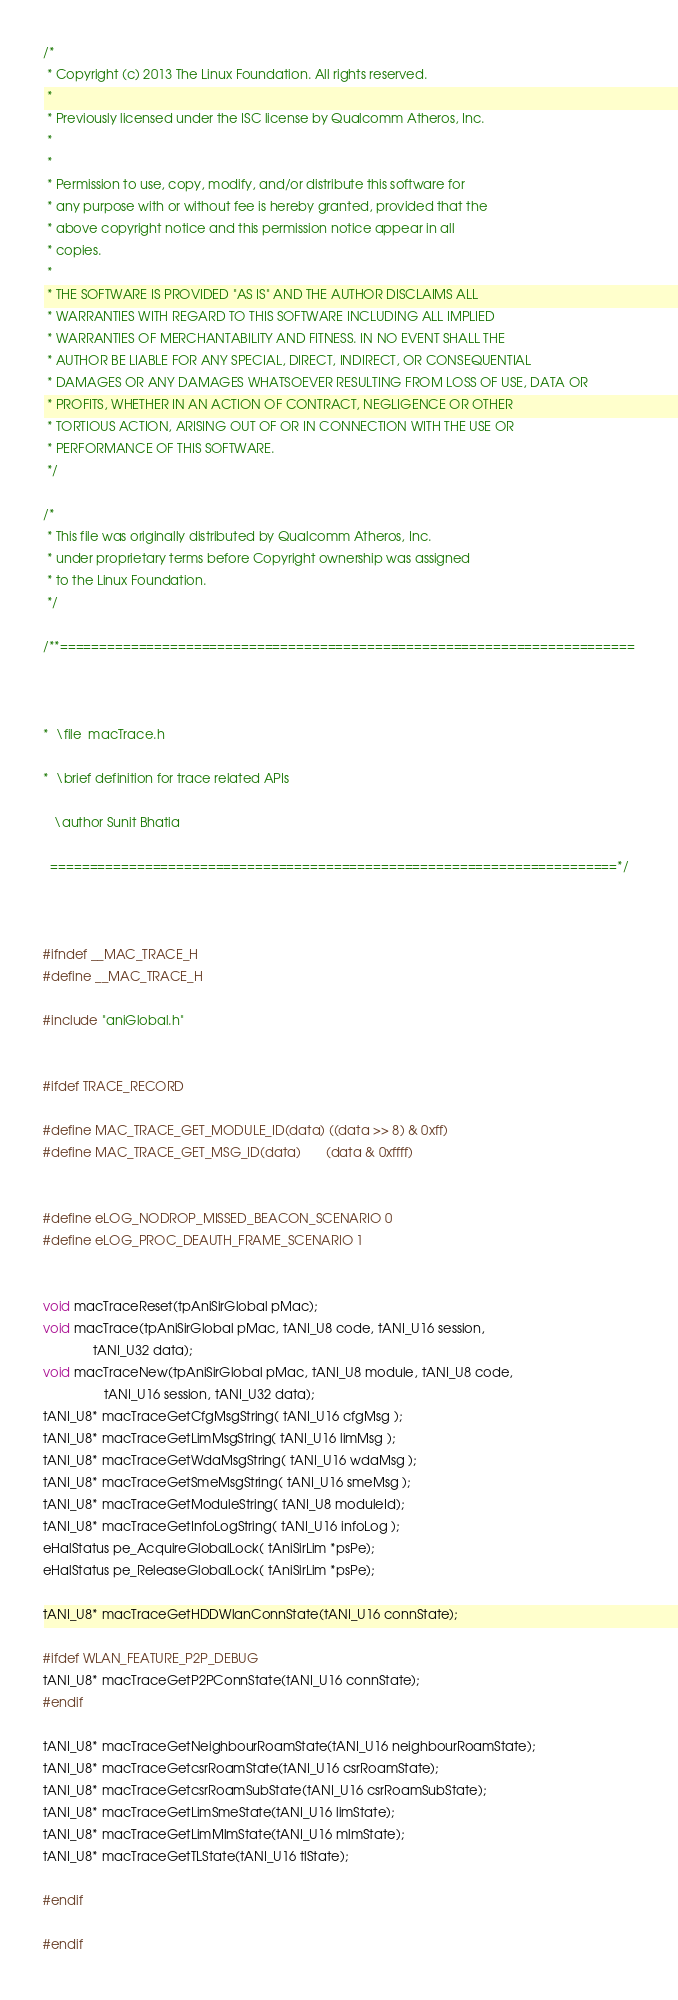<code> <loc_0><loc_0><loc_500><loc_500><_C_>/*
 * Copyright (c) 2013 The Linux Foundation. All rights reserved.
 *
 * Previously licensed under the ISC license by Qualcomm Atheros, Inc.
 *
 *
 * Permission to use, copy, modify, and/or distribute this software for
 * any purpose with or without fee is hereby granted, provided that the
 * above copyright notice and this permission notice appear in all
 * copies.
 *
 * THE SOFTWARE IS PROVIDED "AS IS" AND THE AUTHOR DISCLAIMS ALL
 * WARRANTIES WITH REGARD TO THIS SOFTWARE INCLUDING ALL IMPLIED
 * WARRANTIES OF MERCHANTABILITY AND FITNESS. IN NO EVENT SHALL THE
 * AUTHOR BE LIABLE FOR ANY SPECIAL, DIRECT, INDIRECT, OR CONSEQUENTIAL
 * DAMAGES OR ANY DAMAGES WHATSOEVER RESULTING FROM LOSS OF USE, DATA OR
 * PROFITS, WHETHER IN AN ACTION OF CONTRACT, NEGLIGENCE OR OTHER
 * TORTIOUS ACTION, ARISING OUT OF OR IN CONNECTION WITH THE USE OR
 * PERFORMANCE OF THIS SOFTWARE.
 */

/*
 * This file was originally distributed by Qualcomm Atheros, Inc.
 * under proprietary terms before Copyright ownership was assigned
 * to the Linux Foundation.
 */

/**=========================================================================



*  \file  macTrace.h

*  \brief definition for trace related APIs

   \author Sunit Bhatia

  ========================================================================*/



#ifndef __MAC_TRACE_H
#define __MAC_TRACE_H

#include "aniGlobal.h"


#ifdef TRACE_RECORD

#define MAC_TRACE_GET_MODULE_ID(data) ((data >> 8) & 0xff)
#define MAC_TRACE_GET_MSG_ID(data)       (data & 0xffff)


#define eLOG_NODROP_MISSED_BEACON_SCENARIO 0
#define eLOG_PROC_DEAUTH_FRAME_SCENARIO 1


void macTraceReset(tpAniSirGlobal pMac);
void macTrace(tpAniSirGlobal pMac, tANI_U8 code, tANI_U16 session,
              tANI_U32 data);
void macTraceNew(tpAniSirGlobal pMac, tANI_U8 module, tANI_U8 code,
                 tANI_U16 session, tANI_U32 data);
tANI_U8* macTraceGetCfgMsgString( tANI_U16 cfgMsg );
tANI_U8* macTraceGetLimMsgString( tANI_U16 limMsg );
tANI_U8* macTraceGetWdaMsgString( tANI_U16 wdaMsg );
tANI_U8* macTraceGetSmeMsgString( tANI_U16 smeMsg );
tANI_U8* macTraceGetModuleString( tANI_U8 moduleId);
tANI_U8* macTraceGetInfoLogString( tANI_U16 infoLog );
eHalStatus pe_AcquireGlobalLock( tAniSirLim *psPe);
eHalStatus pe_ReleaseGlobalLock( tAniSirLim *psPe);

tANI_U8* macTraceGetHDDWlanConnState(tANI_U16 connState);

#ifdef WLAN_FEATURE_P2P_DEBUG
tANI_U8* macTraceGetP2PConnState(tANI_U16 connState);
#endif

tANI_U8* macTraceGetNeighbourRoamState(tANI_U16 neighbourRoamState);
tANI_U8* macTraceGetcsrRoamState(tANI_U16 csrRoamState);
tANI_U8* macTraceGetcsrRoamSubState(tANI_U16 csrRoamSubState);
tANI_U8* macTraceGetLimSmeState(tANI_U16 limState);
tANI_U8* macTraceGetLimMlmState(tANI_U16 mlmState);
tANI_U8* macTraceGetTLState(tANI_U16 tlState);

#endif

#endif
</code> 